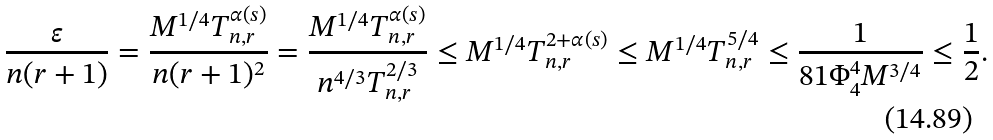<formula> <loc_0><loc_0><loc_500><loc_500>\frac { \varepsilon } { n ( r + 1 ) } = \frac { M ^ { 1 / 4 } T _ { n , r } ^ { \alpha ( s ) } } { n ( r + 1 ) ^ { 2 } } = \frac { M ^ { 1 / 4 } T _ { n , r } ^ { \alpha ( s ) } } { n ^ { 4 / 3 } T _ { n , r } ^ { 2 / 3 } } \leq M ^ { 1 / 4 } T _ { n , r } ^ { 2 + \alpha ( s ) } \leq M ^ { 1 / 4 } T _ { n , r } ^ { 5 / 4 } \leq \frac { 1 } { 8 1 \Phi _ { 4 } ^ { 4 } M ^ { 3 / 4 } } \leq \frac { 1 } { 2 } .</formula> 